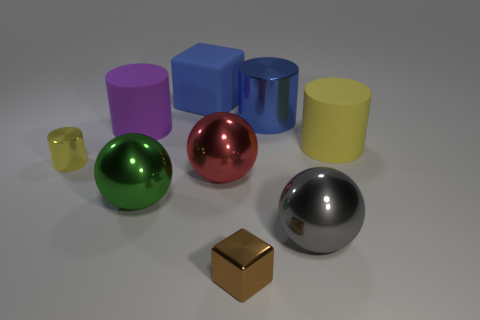Subtract all green cylinders. Subtract all gray balls. How many cylinders are left? 4 Add 1 big brown shiny cylinders. How many objects exist? 10 Subtract all spheres. How many objects are left? 6 Subtract all big blue rubber cubes. Subtract all blue shiny things. How many objects are left? 7 Add 8 big blue cylinders. How many big blue cylinders are left? 9 Add 4 big green things. How many big green things exist? 5 Subtract 1 green balls. How many objects are left? 8 